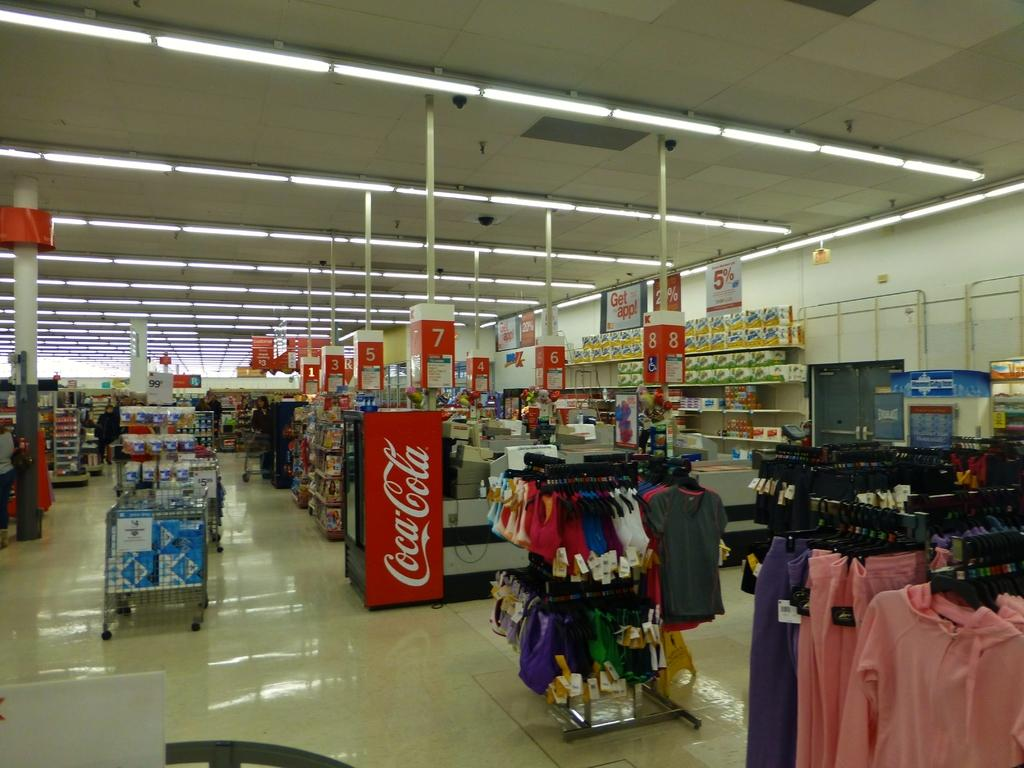<image>
Summarize the visual content of the image. Inside a store area with a Coca-cola drink fridge at the end of an asile. 